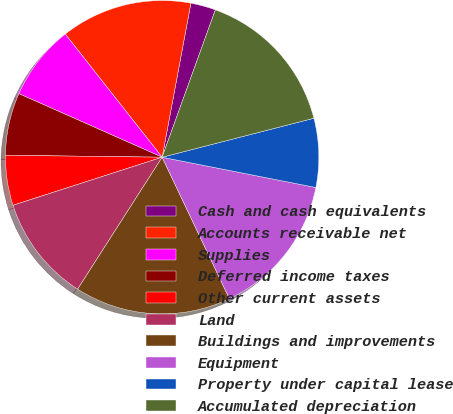Convert chart to OTSL. <chart><loc_0><loc_0><loc_500><loc_500><pie_chart><fcel>Cash and cash equivalents<fcel>Accounts receivable net<fcel>Supplies<fcel>Deferred income taxes<fcel>Other current assets<fcel>Land<fcel>Buildings and improvements<fcel>Equipment<fcel>Property under capital lease<fcel>Accumulated depreciation<nl><fcel>2.58%<fcel>13.55%<fcel>7.74%<fcel>6.45%<fcel>5.16%<fcel>10.97%<fcel>16.13%<fcel>14.84%<fcel>7.1%<fcel>15.48%<nl></chart> 